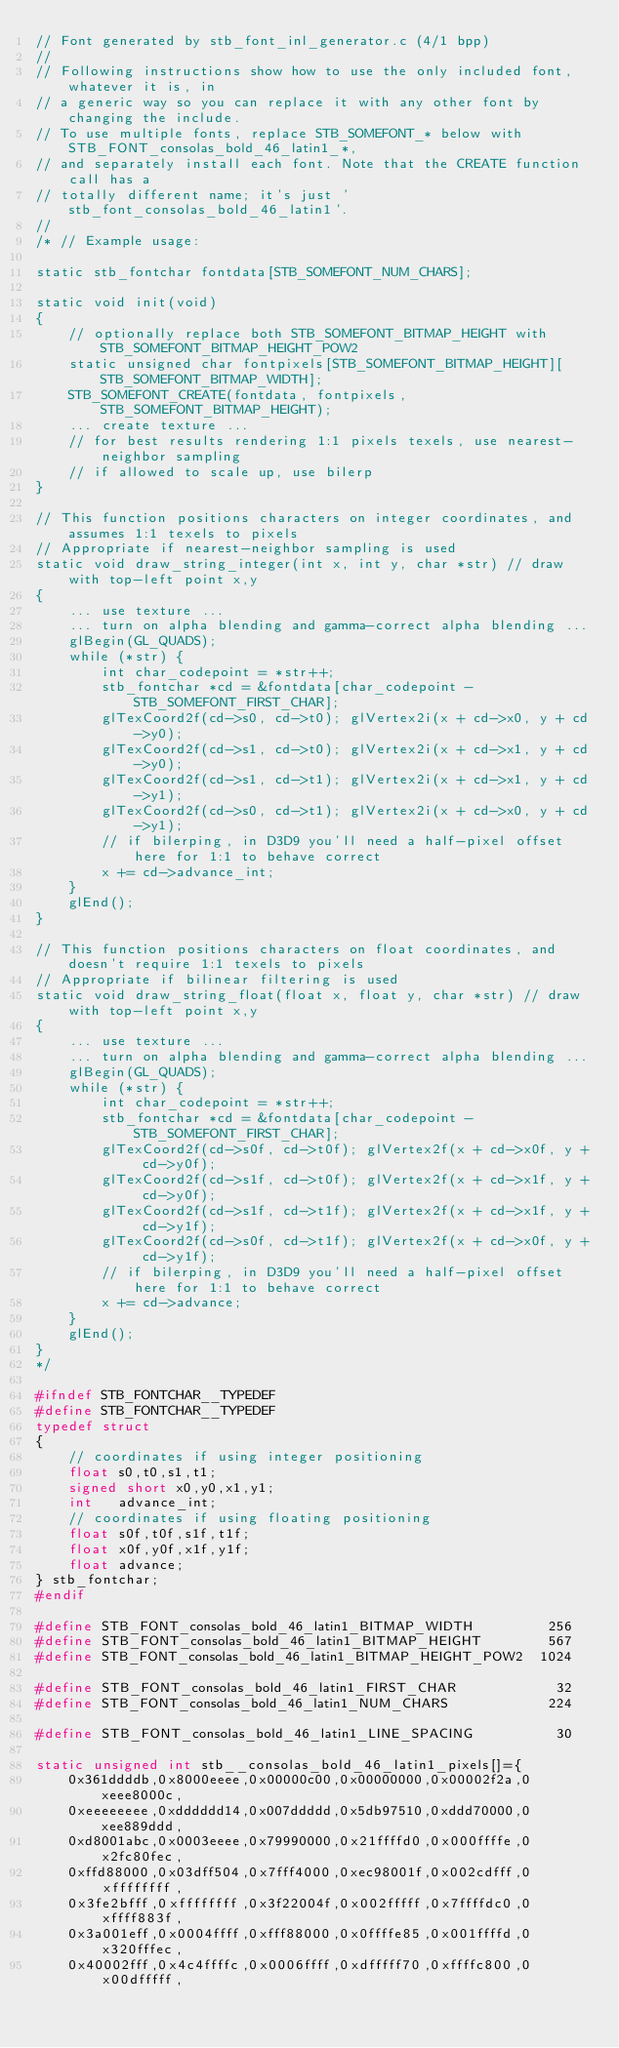Convert code to text. <code><loc_0><loc_0><loc_500><loc_500><_C++_>// Font generated by stb_font_inl_generator.c (4/1 bpp)
//
// Following instructions show how to use the only included font, whatever it is, in
// a generic way so you can replace it with any other font by changing the include.
// To use multiple fonts, replace STB_SOMEFONT_* below with STB_FONT_consolas_bold_46_latin1_*,
// and separately install each font. Note that the CREATE function call has a
// totally different name; it's just 'stb_font_consolas_bold_46_latin1'.
//
/* // Example usage:

static stb_fontchar fontdata[STB_SOMEFONT_NUM_CHARS];

static void init(void)
{
    // optionally replace both STB_SOMEFONT_BITMAP_HEIGHT with STB_SOMEFONT_BITMAP_HEIGHT_POW2
    static unsigned char fontpixels[STB_SOMEFONT_BITMAP_HEIGHT][STB_SOMEFONT_BITMAP_WIDTH];
    STB_SOMEFONT_CREATE(fontdata, fontpixels, STB_SOMEFONT_BITMAP_HEIGHT);
    ... create texture ...
    // for best results rendering 1:1 pixels texels, use nearest-neighbor sampling
    // if allowed to scale up, use bilerp
}

// This function positions characters on integer coordinates, and assumes 1:1 texels to pixels
// Appropriate if nearest-neighbor sampling is used
static void draw_string_integer(int x, int y, char *str) // draw with top-left point x,y
{
    ... use texture ...
    ... turn on alpha blending and gamma-correct alpha blending ...
    glBegin(GL_QUADS);
    while (*str) {
        int char_codepoint = *str++;
        stb_fontchar *cd = &fontdata[char_codepoint - STB_SOMEFONT_FIRST_CHAR];
        glTexCoord2f(cd->s0, cd->t0); glVertex2i(x + cd->x0, y + cd->y0);
        glTexCoord2f(cd->s1, cd->t0); glVertex2i(x + cd->x1, y + cd->y0);
        glTexCoord2f(cd->s1, cd->t1); glVertex2i(x + cd->x1, y + cd->y1);
        glTexCoord2f(cd->s0, cd->t1); glVertex2i(x + cd->x0, y + cd->y1);
        // if bilerping, in D3D9 you'll need a half-pixel offset here for 1:1 to behave correct
        x += cd->advance_int;
    }
    glEnd();
}

// This function positions characters on float coordinates, and doesn't require 1:1 texels to pixels
// Appropriate if bilinear filtering is used
static void draw_string_float(float x, float y, char *str) // draw with top-left point x,y
{
    ... use texture ...
    ... turn on alpha blending and gamma-correct alpha blending ...
    glBegin(GL_QUADS);
    while (*str) {
        int char_codepoint = *str++;
        stb_fontchar *cd = &fontdata[char_codepoint - STB_SOMEFONT_FIRST_CHAR];
        glTexCoord2f(cd->s0f, cd->t0f); glVertex2f(x + cd->x0f, y + cd->y0f);
        glTexCoord2f(cd->s1f, cd->t0f); glVertex2f(x + cd->x1f, y + cd->y0f);
        glTexCoord2f(cd->s1f, cd->t1f); glVertex2f(x + cd->x1f, y + cd->y1f);
        glTexCoord2f(cd->s0f, cd->t1f); glVertex2f(x + cd->x0f, y + cd->y1f);
        // if bilerping, in D3D9 you'll need a half-pixel offset here for 1:1 to behave correct
        x += cd->advance;
    }
    glEnd();
}
*/

#ifndef STB_FONTCHAR__TYPEDEF
#define STB_FONTCHAR__TYPEDEF
typedef struct
{
    // coordinates if using integer positioning
    float s0,t0,s1,t1;
    signed short x0,y0,x1,y1;
    int   advance_int;
    // coordinates if using floating positioning
    float s0f,t0f,s1f,t1f;
    float x0f,y0f,x1f,y1f;
    float advance;
} stb_fontchar;
#endif

#define STB_FONT_consolas_bold_46_latin1_BITMAP_WIDTH         256
#define STB_FONT_consolas_bold_46_latin1_BITMAP_HEIGHT        567
#define STB_FONT_consolas_bold_46_latin1_BITMAP_HEIGHT_POW2  1024

#define STB_FONT_consolas_bold_46_latin1_FIRST_CHAR            32
#define STB_FONT_consolas_bold_46_latin1_NUM_CHARS            224

#define STB_FONT_consolas_bold_46_latin1_LINE_SPACING          30

static unsigned int stb__consolas_bold_46_latin1_pixels[]={
    0x361ddddb,0x8000eeee,0x00000c00,0x00000000,0x00002f2a,0xeee8000c,
    0xeeeeeeee,0xdddddd14,0x007ddddd,0x5db97510,0xddd70000,0xee889ddd,
    0xd8001abc,0x0003eeee,0x79990000,0x21ffffd0,0x000ffffe,0x2fc80fec,
    0xffd88000,0x03dff504,0x7fff4000,0xec98001f,0x002cdfff,0xffffffff,
    0x3fe2bfff,0xffffffff,0x3f22004f,0x002fffff,0x7ffffdc0,0xffff883f,
    0x3a001eff,0x0004ffff,0xfff88000,0x0ffffe85,0x001ffffd,0x320fffec,
    0x40002fff,0x4c4ffffc,0x0006ffff,0xdfffff70,0xffffc800,0x00dfffff,</code> 